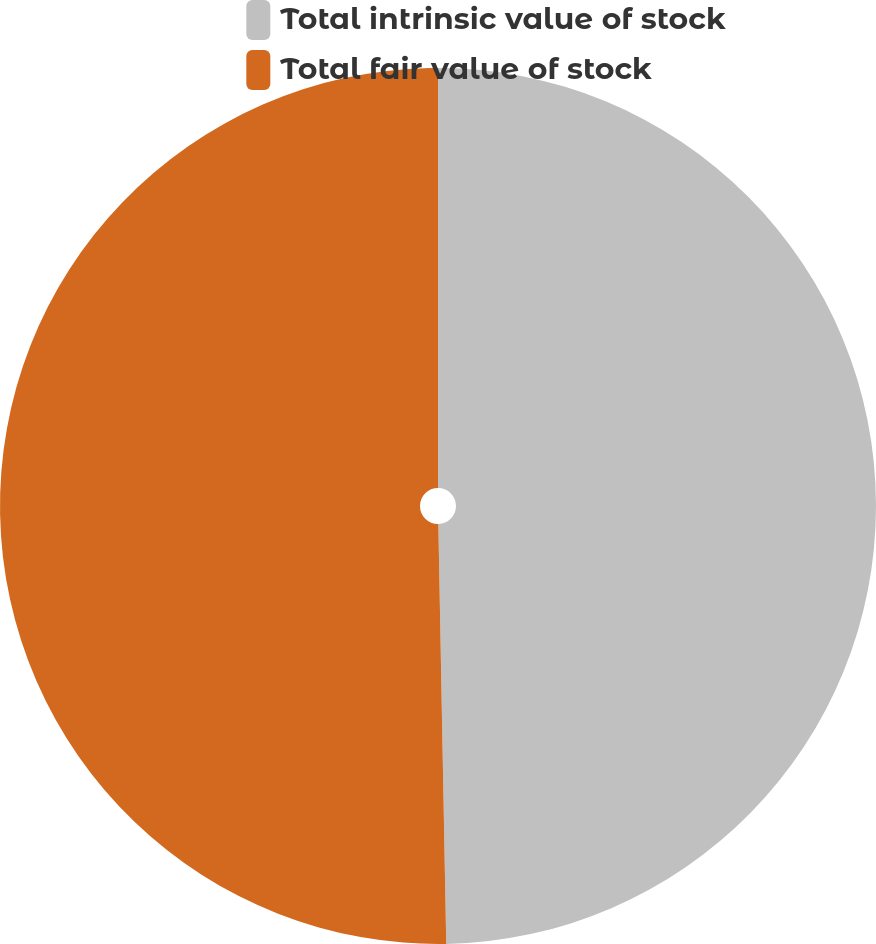Convert chart to OTSL. <chart><loc_0><loc_0><loc_500><loc_500><pie_chart><fcel>Total intrinsic value of stock<fcel>Total fair value of stock<nl><fcel>49.7%<fcel>50.3%<nl></chart> 